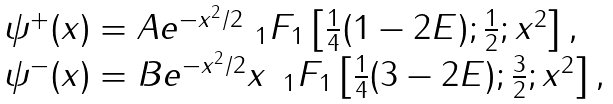Convert formula to latex. <formula><loc_0><loc_0><loc_500><loc_500>\begin{array} { l } \psi ^ { + } ( x ) = A e ^ { - x ^ { 2 } / 2 } { \ } _ { 1 } F _ { 1 } \left [ { \frac { 1 } { 4 } ( 1 - 2 E ) ; \frac { 1 } { 2 } ; x ^ { 2 } } \right ] , \\ \psi ^ { - } ( x ) = B e ^ { - x ^ { 2 } / 2 } x \, { \ } _ { 1 } F _ { 1 } \left [ { \frac { 1 } { 4 } ( 3 - 2 E ) ; \frac { 3 } { 2 } ; x ^ { 2 } } \right ] , \end{array}</formula> 